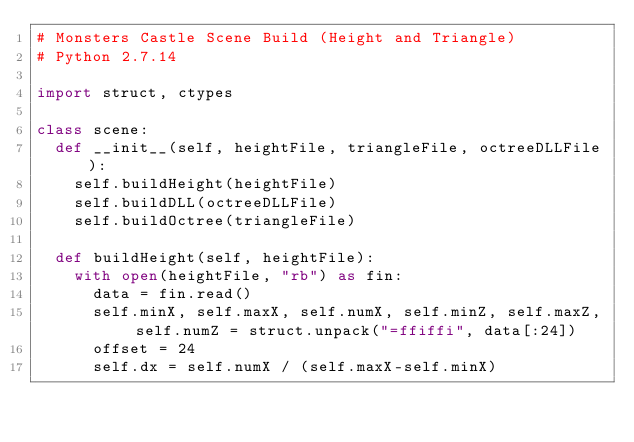Convert code to text. <code><loc_0><loc_0><loc_500><loc_500><_Python_># Monsters Castle Scene Build (Height and Triangle)
# Python 2.7.14

import struct, ctypes

class scene:
	def __init__(self, heightFile, triangleFile, octreeDLLFile):
		self.buildHeight(heightFile)
		self.buildDLL(octreeDLLFile)
		self.buildOctree(triangleFile)
				
	def buildHeight(self, heightFile):
		with open(heightFile, "rb") as fin:
			data = fin.read()
			self.minX, self.maxX, self.numX, self.minZ, self.maxZ, self.numZ = struct.unpack("=ffiffi", data[:24])
			offset = 24
			self.dx = self.numX / (self.maxX-self.minX)</code> 